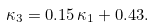Convert formula to latex. <formula><loc_0><loc_0><loc_500><loc_500>\kappa _ { 3 } = 0 . 1 5 \, \kappa _ { 1 } + 0 . 4 3 .</formula> 